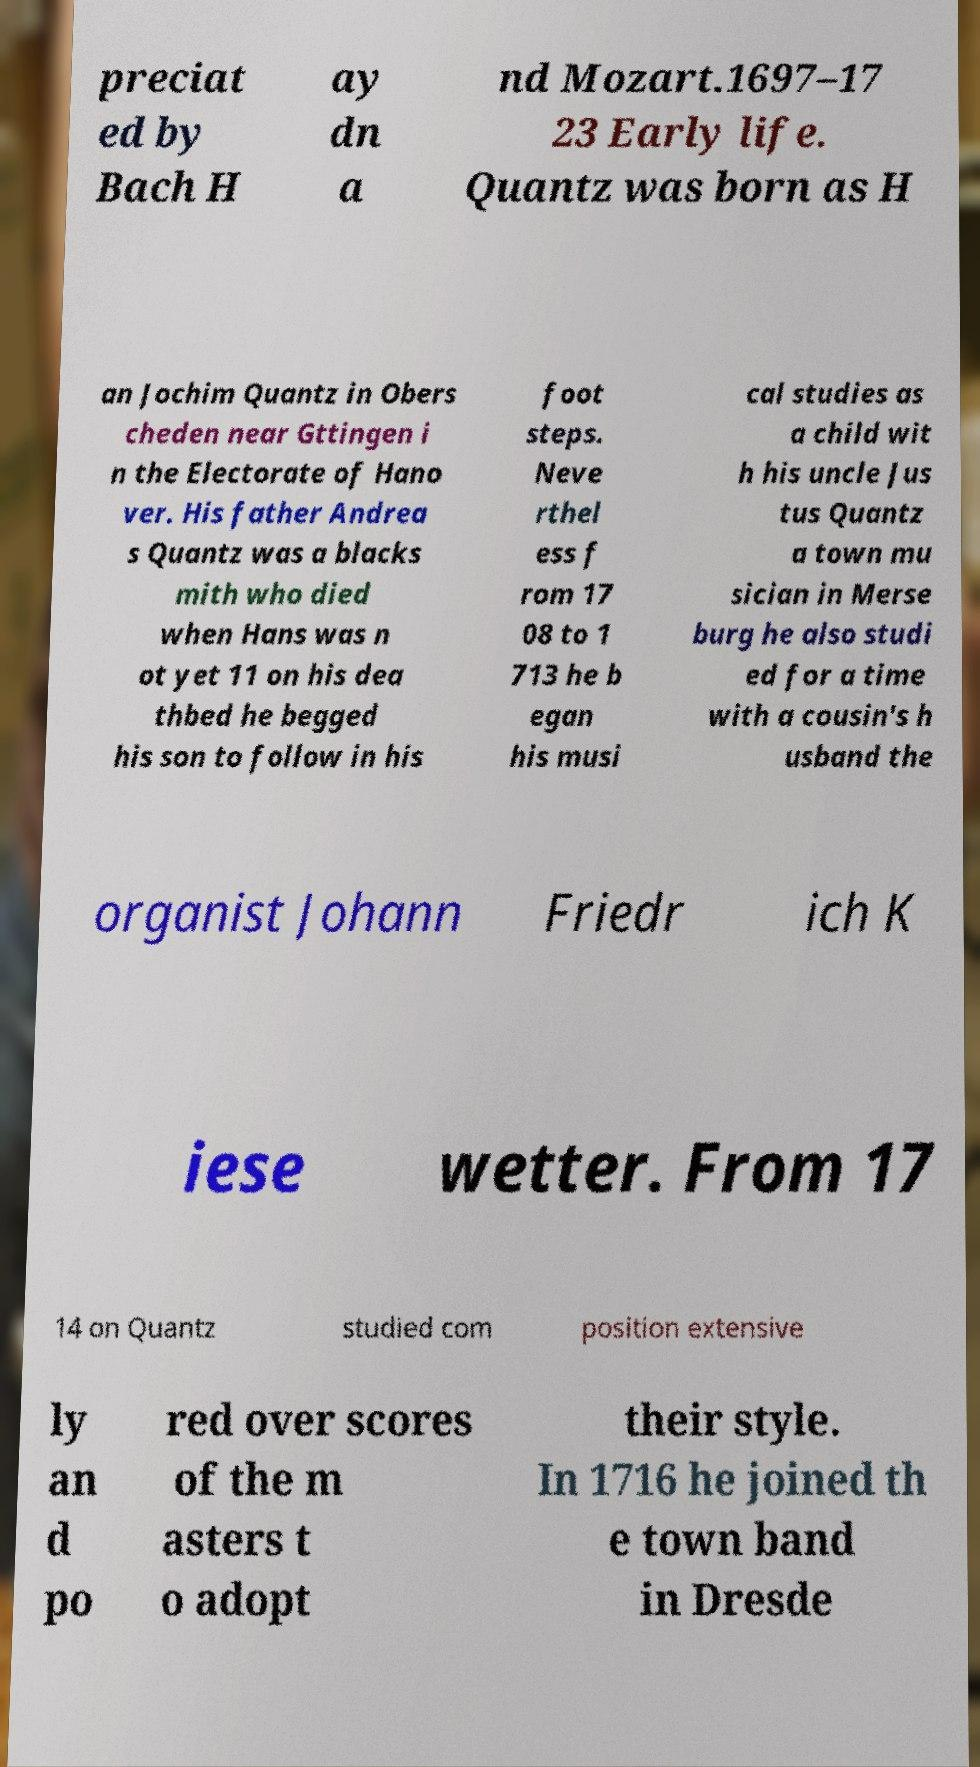Could you extract and type out the text from this image? preciat ed by Bach H ay dn a nd Mozart.1697–17 23 Early life. Quantz was born as H an Jochim Quantz in Obers cheden near Gttingen i n the Electorate of Hano ver. His father Andrea s Quantz was a blacks mith who died when Hans was n ot yet 11 on his dea thbed he begged his son to follow in his foot steps. Neve rthel ess f rom 17 08 to 1 713 he b egan his musi cal studies as a child wit h his uncle Jus tus Quantz a town mu sician in Merse burg he also studi ed for a time with a cousin's h usband the organist Johann Friedr ich K iese wetter. From 17 14 on Quantz studied com position extensive ly an d po red over scores of the m asters t o adopt their style. In 1716 he joined th e town band in Dresde 